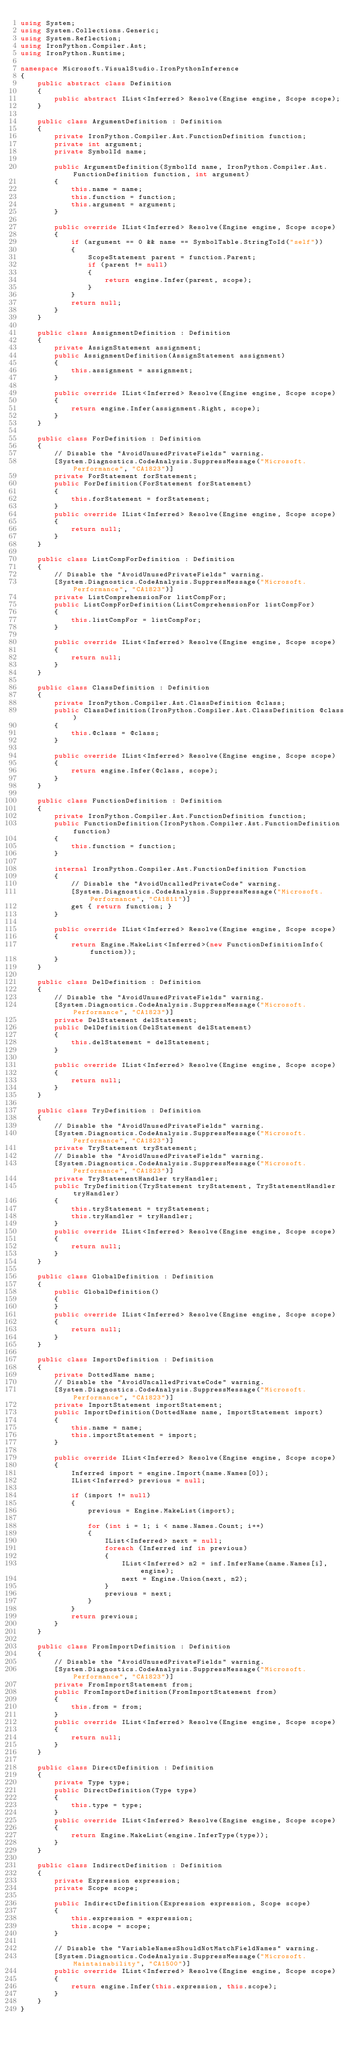<code> <loc_0><loc_0><loc_500><loc_500><_C#_>using System;
using System.Collections.Generic;
using System.Reflection;
using IronPython.Compiler.Ast;
using IronPython.Runtime;

namespace Microsoft.VisualStudio.IronPythonInference
{
    public abstract class Definition
    {
        public abstract IList<Inferred> Resolve(Engine engine, Scope scope);
    }

    public class ArgumentDefinition : Definition
    {
        private IronPython.Compiler.Ast.FunctionDefinition function;
        private int argument;
        private SymbolId name;

        public ArgumentDefinition(SymbolId name, IronPython.Compiler.Ast.FunctionDefinition function, int argument)
        {
            this.name = name;
            this.function = function;
            this.argument = argument;
        }

        public override IList<Inferred> Resolve(Engine engine, Scope scope)
        {
            if (argument == 0 && name == SymbolTable.StringToId("self"))
            {
                ScopeStatement parent = function.Parent;
                if (parent != null)
                {
                    return engine.Infer(parent, scope);
                }
            }
            return null;
        }
    }

    public class AssignmentDefinition : Definition
    {
        private AssignStatement assignment;
        public AssignmentDefinition(AssignStatement assignment)
        {
            this.assignment = assignment;
        }

        public override IList<Inferred> Resolve(Engine engine, Scope scope)
        {
            return engine.Infer(assignment.Right, scope);
        }
    }

    public class ForDefinition : Definition
    {
        // Disable the "AvoidUnusedPrivateFields" warning.
        [System.Diagnostics.CodeAnalysis.SuppressMessage("Microsoft.Performance", "CA1823")]
        private ForStatement forStatement;
        public ForDefinition(ForStatement forStatement)
        {
            this.forStatement = forStatement;
        }
        public override IList<Inferred> Resolve(Engine engine, Scope scope)
        {
            return null;
        }
    }

    public class ListCompForDefinition : Definition
    {
        // Disable the "AvoidUnusedPrivateFields" warning.
        [System.Diagnostics.CodeAnalysis.SuppressMessage("Microsoft.Performance", "CA1823")]
        private ListComprehensionFor listCompFor;
        public ListCompForDefinition(ListComprehensionFor listCompFor)
        {
            this.listCompFor = listCompFor;
        }

        public override IList<Inferred> Resolve(Engine engine, Scope scope)
        {
            return null;
        }
    }

    public class ClassDefinition : Definition
    {
        private IronPython.Compiler.Ast.ClassDefinition @class;
        public ClassDefinition(IronPython.Compiler.Ast.ClassDefinition @class)
        {
            this.@class = @class;
        }

        public override IList<Inferred> Resolve(Engine engine, Scope scope)
        {
            return engine.Infer(@class, scope);
        }
    }

    public class FunctionDefinition : Definition
    {
        private IronPython.Compiler.Ast.FunctionDefinition function;
        public FunctionDefinition(IronPython.Compiler.Ast.FunctionDefinition function)
        {
            this.function = function;
        }

        internal IronPython.Compiler.Ast.FunctionDefinition Function
        {
            // Disable the "AvoidUncalledPrivateCode" warning.
            [System.Diagnostics.CodeAnalysis.SuppressMessage("Microsoft.Performance", "CA1811")]
            get { return function; }
        }

        public override IList<Inferred> Resolve(Engine engine, Scope scope)
        {
            return Engine.MakeList<Inferred>(new FunctionDefinitionInfo(function));
        }
    }

    public class DelDefinition : Definition
    {
        // Disable the "AvoidUnusedPrivateFields" warning.
        [System.Diagnostics.CodeAnalysis.SuppressMessage("Microsoft.Performance", "CA1823")]
        private DelStatement delStatement;
        public DelDefinition(DelStatement delStatement)
        {
            this.delStatement = delStatement;
        }

        public override IList<Inferred> Resolve(Engine engine, Scope scope)
        {
            return null;
        }
    }

    public class TryDefinition : Definition
    {
        // Disable the "AvoidUnusedPrivateFields" warning.
        [System.Diagnostics.CodeAnalysis.SuppressMessage("Microsoft.Performance", "CA1823")]
        private TryStatement tryStatement;
        // Disable the "AvoidUnusedPrivateFields" warning.
        [System.Diagnostics.CodeAnalysis.SuppressMessage("Microsoft.Performance", "CA1823")]
        private TryStatementHandler tryHandler;
        public TryDefinition(TryStatement tryStatement, TryStatementHandler tryHandler)
        {
            this.tryStatement = tryStatement;
            this.tryHandler = tryHandler;
        }
        public override IList<Inferred> Resolve(Engine engine, Scope scope)
        {
            return null;
        }
    }

    public class GlobalDefinition : Definition
    {
        public GlobalDefinition()
        {
        }
        public override IList<Inferred> Resolve(Engine engine, Scope scope)
        {
            return null;
        }
    }

    public class ImportDefinition : Definition
    {
        private DottedName name;
        // Disable the "AvoidUncalledPrivateCode" warning.
        [System.Diagnostics.CodeAnalysis.SuppressMessage("Microsoft.Performance", "CA1823")]
        private ImportStatement importStatement;
        public ImportDefinition(DottedName name, ImportStatement import)
        {
            this.name = name;
            this.importStatement = import;
        }

        public override IList<Inferred> Resolve(Engine engine, Scope scope)
        {
            Inferred import = engine.Import(name.Names[0]);
            IList<Inferred> previous = null;

            if (import != null)
            {
                previous = Engine.MakeList(import);

                for (int i = 1; i < name.Names.Count; i++)
                {
                    IList<Inferred> next = null;
                    foreach (Inferred inf in previous)
                    {
                        IList<Inferred> n2 = inf.InferName(name.Names[i], engine);
                        next = Engine.Union(next, n2);
                    }
                    previous = next;
                }
            }
            return previous;
        }
    }

    public class FromImportDefinition : Definition
    {
        // Disable the "AvoidUnusedPrivateFields" warning.
        [System.Diagnostics.CodeAnalysis.SuppressMessage("Microsoft.Performance", "CA1823")]
        private FromImportStatement from;
        public FromImportDefinition(FromImportStatement from)
        {
            this.from = from;
        }
        public override IList<Inferred> Resolve(Engine engine, Scope scope)
        {
            return null;
        }
    }

    public class DirectDefinition : Definition
    {
        private Type type;
        public DirectDefinition(Type type)
        {
            this.type = type;
        }
        public override IList<Inferred> Resolve(Engine engine, Scope scope)
        {
            return Engine.MakeList(engine.InferType(type));
        }
    }

    public class IndirectDefinition : Definition
    {
        private Expression expression;
        private Scope scope;

        public IndirectDefinition(Expression expression, Scope scope)
        {
            this.expression = expression;
            this.scope = scope;
        }

        // Disable the "VariableNamesShouldNotMatchFieldNames" warning.
        [System.Diagnostics.CodeAnalysis.SuppressMessage("Microsoft.Maintainability", "CA1500")]
        public override IList<Inferred> Resolve(Engine engine, Scope scope)
        {
            return engine.Infer(this.expression, this.scope);
        }
    }
}
</code> 